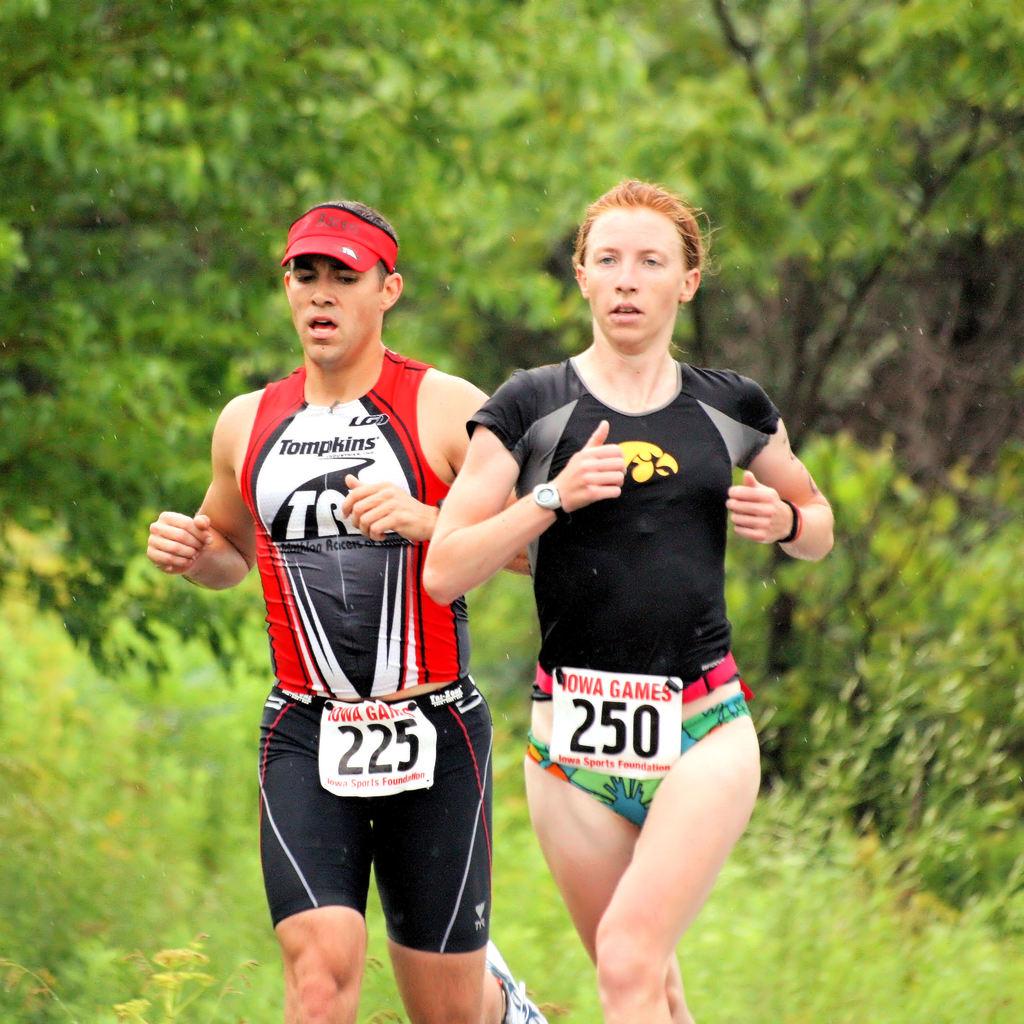What is the women's number?
Ensure brevity in your answer.  250. What is the man race number?
Offer a very short reply. 225. 